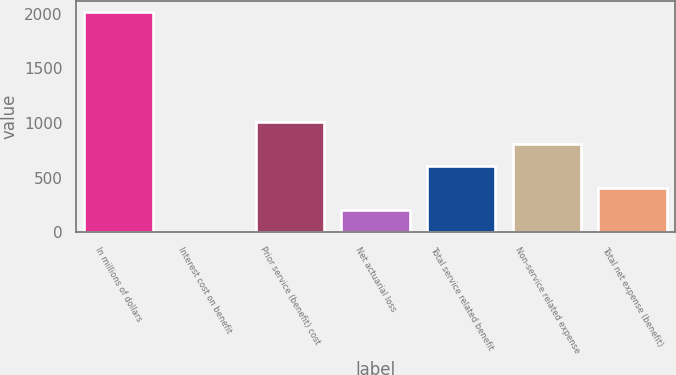Convert chart to OTSL. <chart><loc_0><loc_0><loc_500><loc_500><bar_chart><fcel>In millions of dollars<fcel>Interest cost on benefit<fcel>Prior service (benefit) cost<fcel>Net actuarial loss<fcel>Total service related benefit<fcel>Non-service related expense<fcel>Total net expense (benefit)<nl><fcel>2017<fcel>2<fcel>1009.5<fcel>203.5<fcel>606.5<fcel>808<fcel>405<nl></chart> 